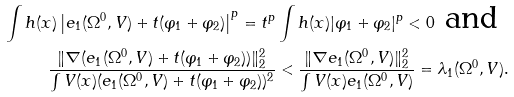Convert formula to latex. <formula><loc_0><loc_0><loc_500><loc_500>\int h ( x ) \left | e _ { 1 } ( \Omega ^ { 0 } , V ) + t ( \varphi _ { 1 } + \varphi _ { 2 } ) \right | ^ { p } = t ^ { p } \int h ( x ) | \varphi _ { 1 } + \varphi _ { 2 } | ^ { p } < 0 \text { and } \\ \frac { \| \nabla ( e _ { 1 } ( \Omega ^ { 0 } , V ) + t ( \varphi _ { 1 } + \varphi _ { 2 } ) ) \| _ { 2 } ^ { 2 } } { \int V ( x ) ( e _ { 1 } ( \Omega ^ { 0 } , V ) + t ( \varphi _ { 1 } + \varphi _ { 2 } ) ) ^ { 2 } } < \frac { \| \nabla e _ { 1 } ( \Omega ^ { 0 } , V ) \| _ { 2 } ^ { 2 } } { \int V ( x ) e _ { 1 } ( \Omega ^ { 0 } , V ) } = \lambda _ { 1 } ( \Omega ^ { 0 } , V ) .</formula> 